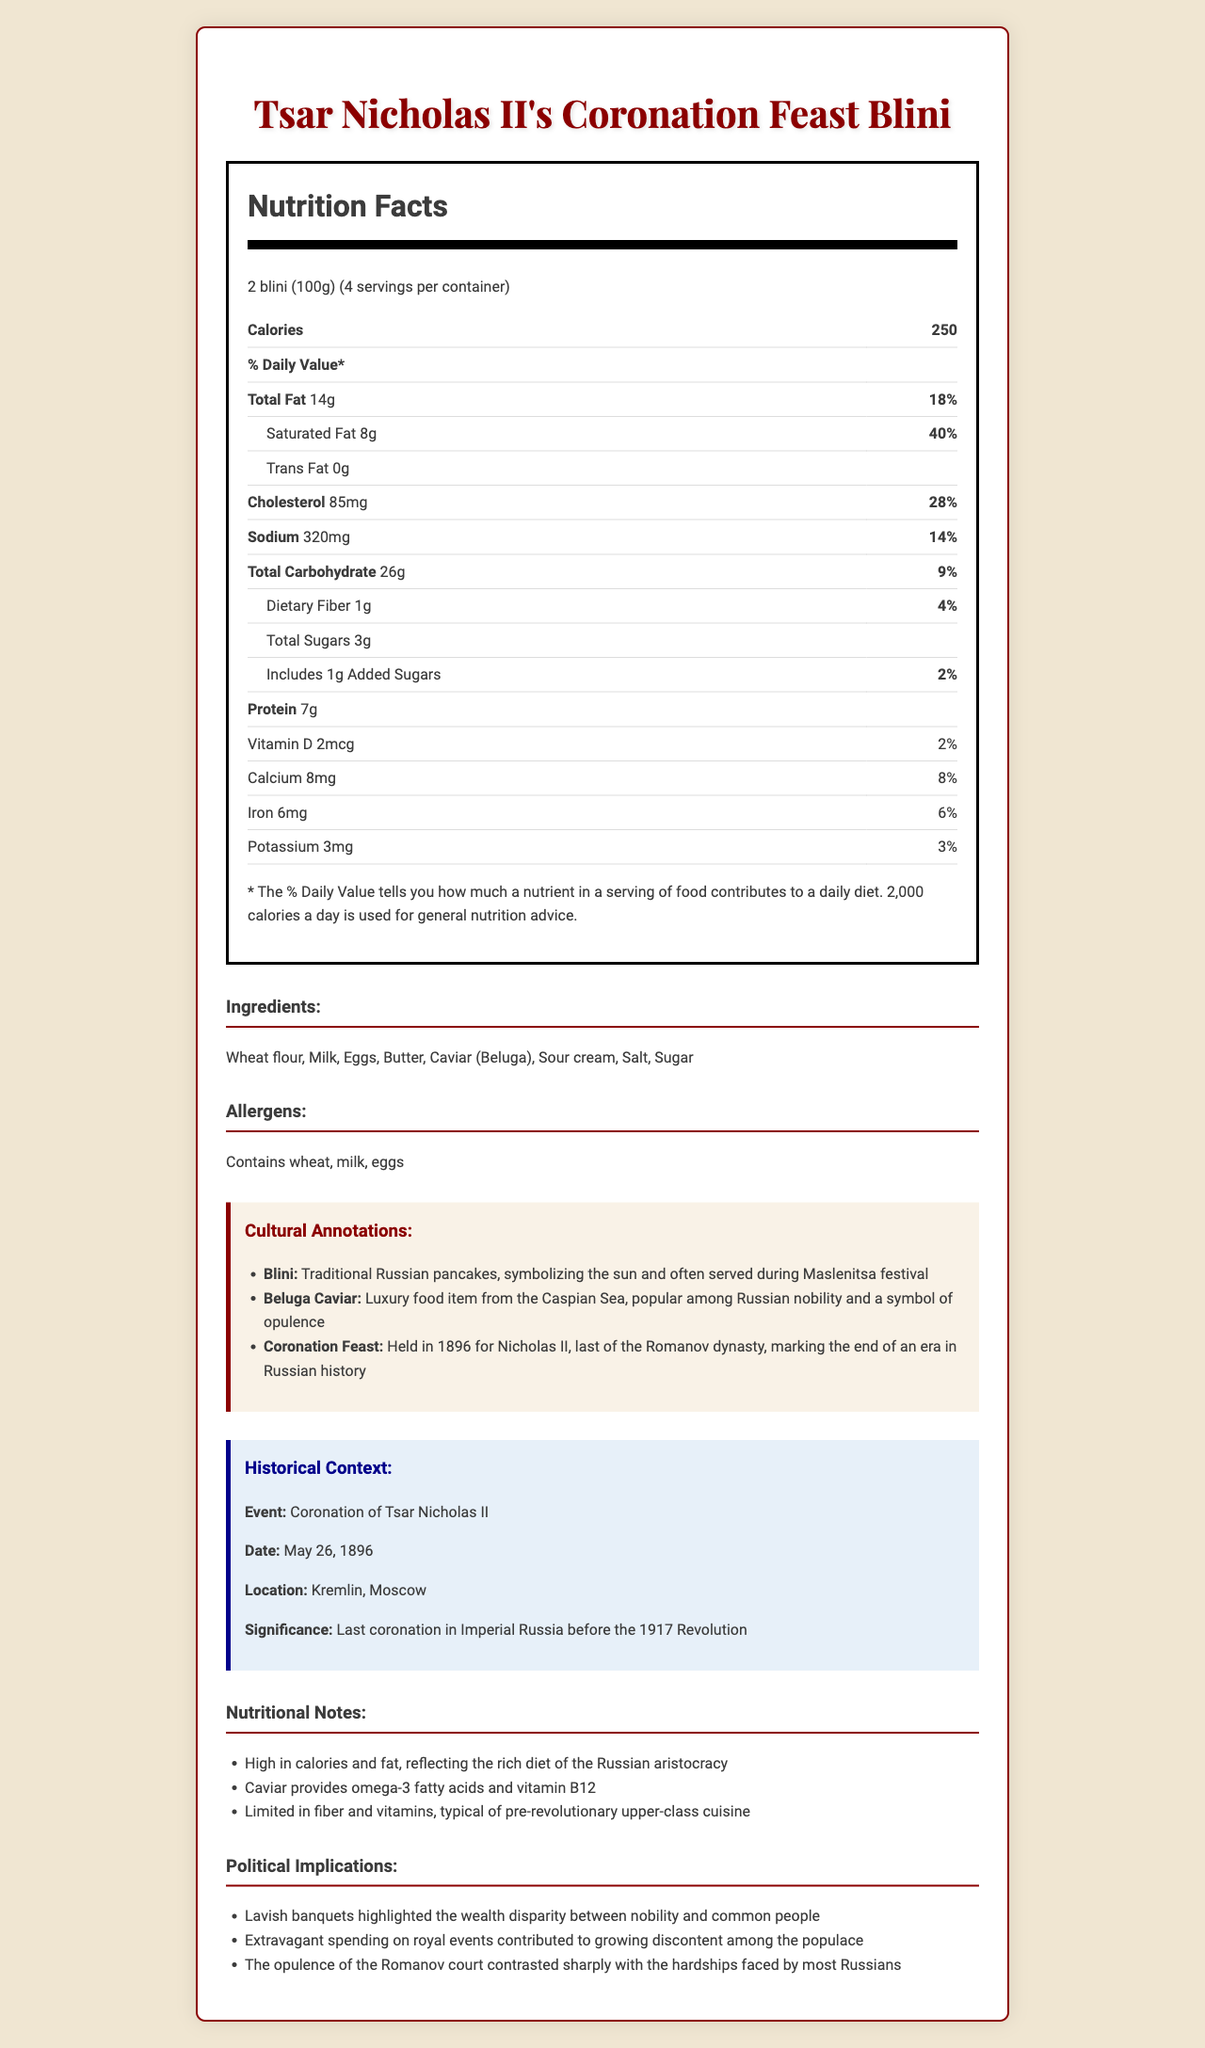how many calories are in a serving of Tsar Nicholas II's Coronation Feast Blini? The document states that there are 250 calories per serving, which is 2 blini (100g).
Answer: 250 what are the main ingredients listed on the nutrition label? These ingredients are listed in the document under the "Ingredients" section.
Answer: Wheat flour, Milk, Eggs, Butter, Caviar (Beluga), Sour cream, Salt, Sugar which luxury item is included in the Tsar's Blini? Beluga Caviar is mentioned in both the ingredients and the cultural annotations, indicating it is a luxury item.
Answer: Beluga Caviar what percentage of the Daily Value is the saturated fat content per serving? The document shows that 8g of saturated fat per serving is 40% of the Daily Value.
Answer: 40% are there any common allergens present in this meal? The allergens section lists wheat, milk, and eggs.
Answer: Yes what is the amount of sodium in each serving? A. 200mg B. 250mg C. 320mg D. 400mg The nutrition facts show that each serving contains 320mg of sodium.
Answer: C. 320mg how does the percentage of calories from fat compare to the total calorie count? A. Less than 30% B. Between 30% and 50% C. More than 50% The total fat is 14g. Since 1g of fat equals 9 calories, 14g accounts for 126 calories from fat out of a total of 250 calories. This is between 30% and 50%.
Answer: B. Between 30% and 50% is the nutritional content more typical of contemporary fast food or aristocratic pre-revolutionary cuisine? The nutritional notes section clarifies that high calories and fat content are typical of the rich diet of the Russian aristocracy.
Answer: Aristocratic pre-revolutionary cuisine does the document mention any political implications related to the meal? The political implications section discusses wealth disparity, extravagant spending, and growing discontent among the populace.
Answer: Yes summarize the main idea of the document. This summary includes key sections and identifies what the document covers.
Answer: The document provides the nutrition facts, ingredients, and allergens for Tsar Nicholas II's Coronation Feast Blini, a traditional Russian dish. It includes cultural annotations, historical context of the 1896 coronation, nutritional notes typical of Russian aristocratic cuisine, and the political implications of such opulence. how does the meal reflect the wealth disparity in pre-revolutionary Russia? This is explained in the political implications section, which discusses wealth disparity and opulence.
Answer: The lavish and high-calorie meal highlights the stark contrast between the diet of the Russian aristocracy and the common people. what historical event is associated with Tsar Nicholas II's Blini? A. Russian Revolution B. Tsar Nicholas II’s Coronation C. Bolshevik Revolution D. Moscow Winter Festival The historical context section states that the meal is associated with the coronation event of Tsar Nicholas II.
Answer: B. Tsar Nicholas II’s Coronation how much dietary fiber is in a serving of blini? In the nutrition facts section, it indicates that there is 1g dietary fiber per serving.
Answer: 1g what luxurious ingredient provides omega-3 fatty acids and vitamin b12? The nutritional notes mention that caviar is high in omega-3 fatty acids and vitamin B12.
Answer: Caviar (Beluga) what is the historical significance of the coronation event described in the document? The historical context section provides this specific detail.
Answer: It marks the last coronation in Imperial Russia before the 1917 Revolution. which cultural annotation is unanswerable based on visual information provided in the document? This information is not mentioned or inferable from the provided document.
Answer: The annual quantity of Beluga Caviar consumed by Russian nobility. 